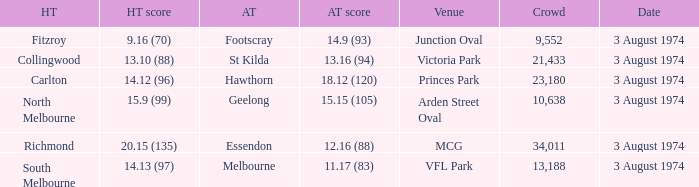Which Home team has a Venue of arden street oval? North Melbourne. 